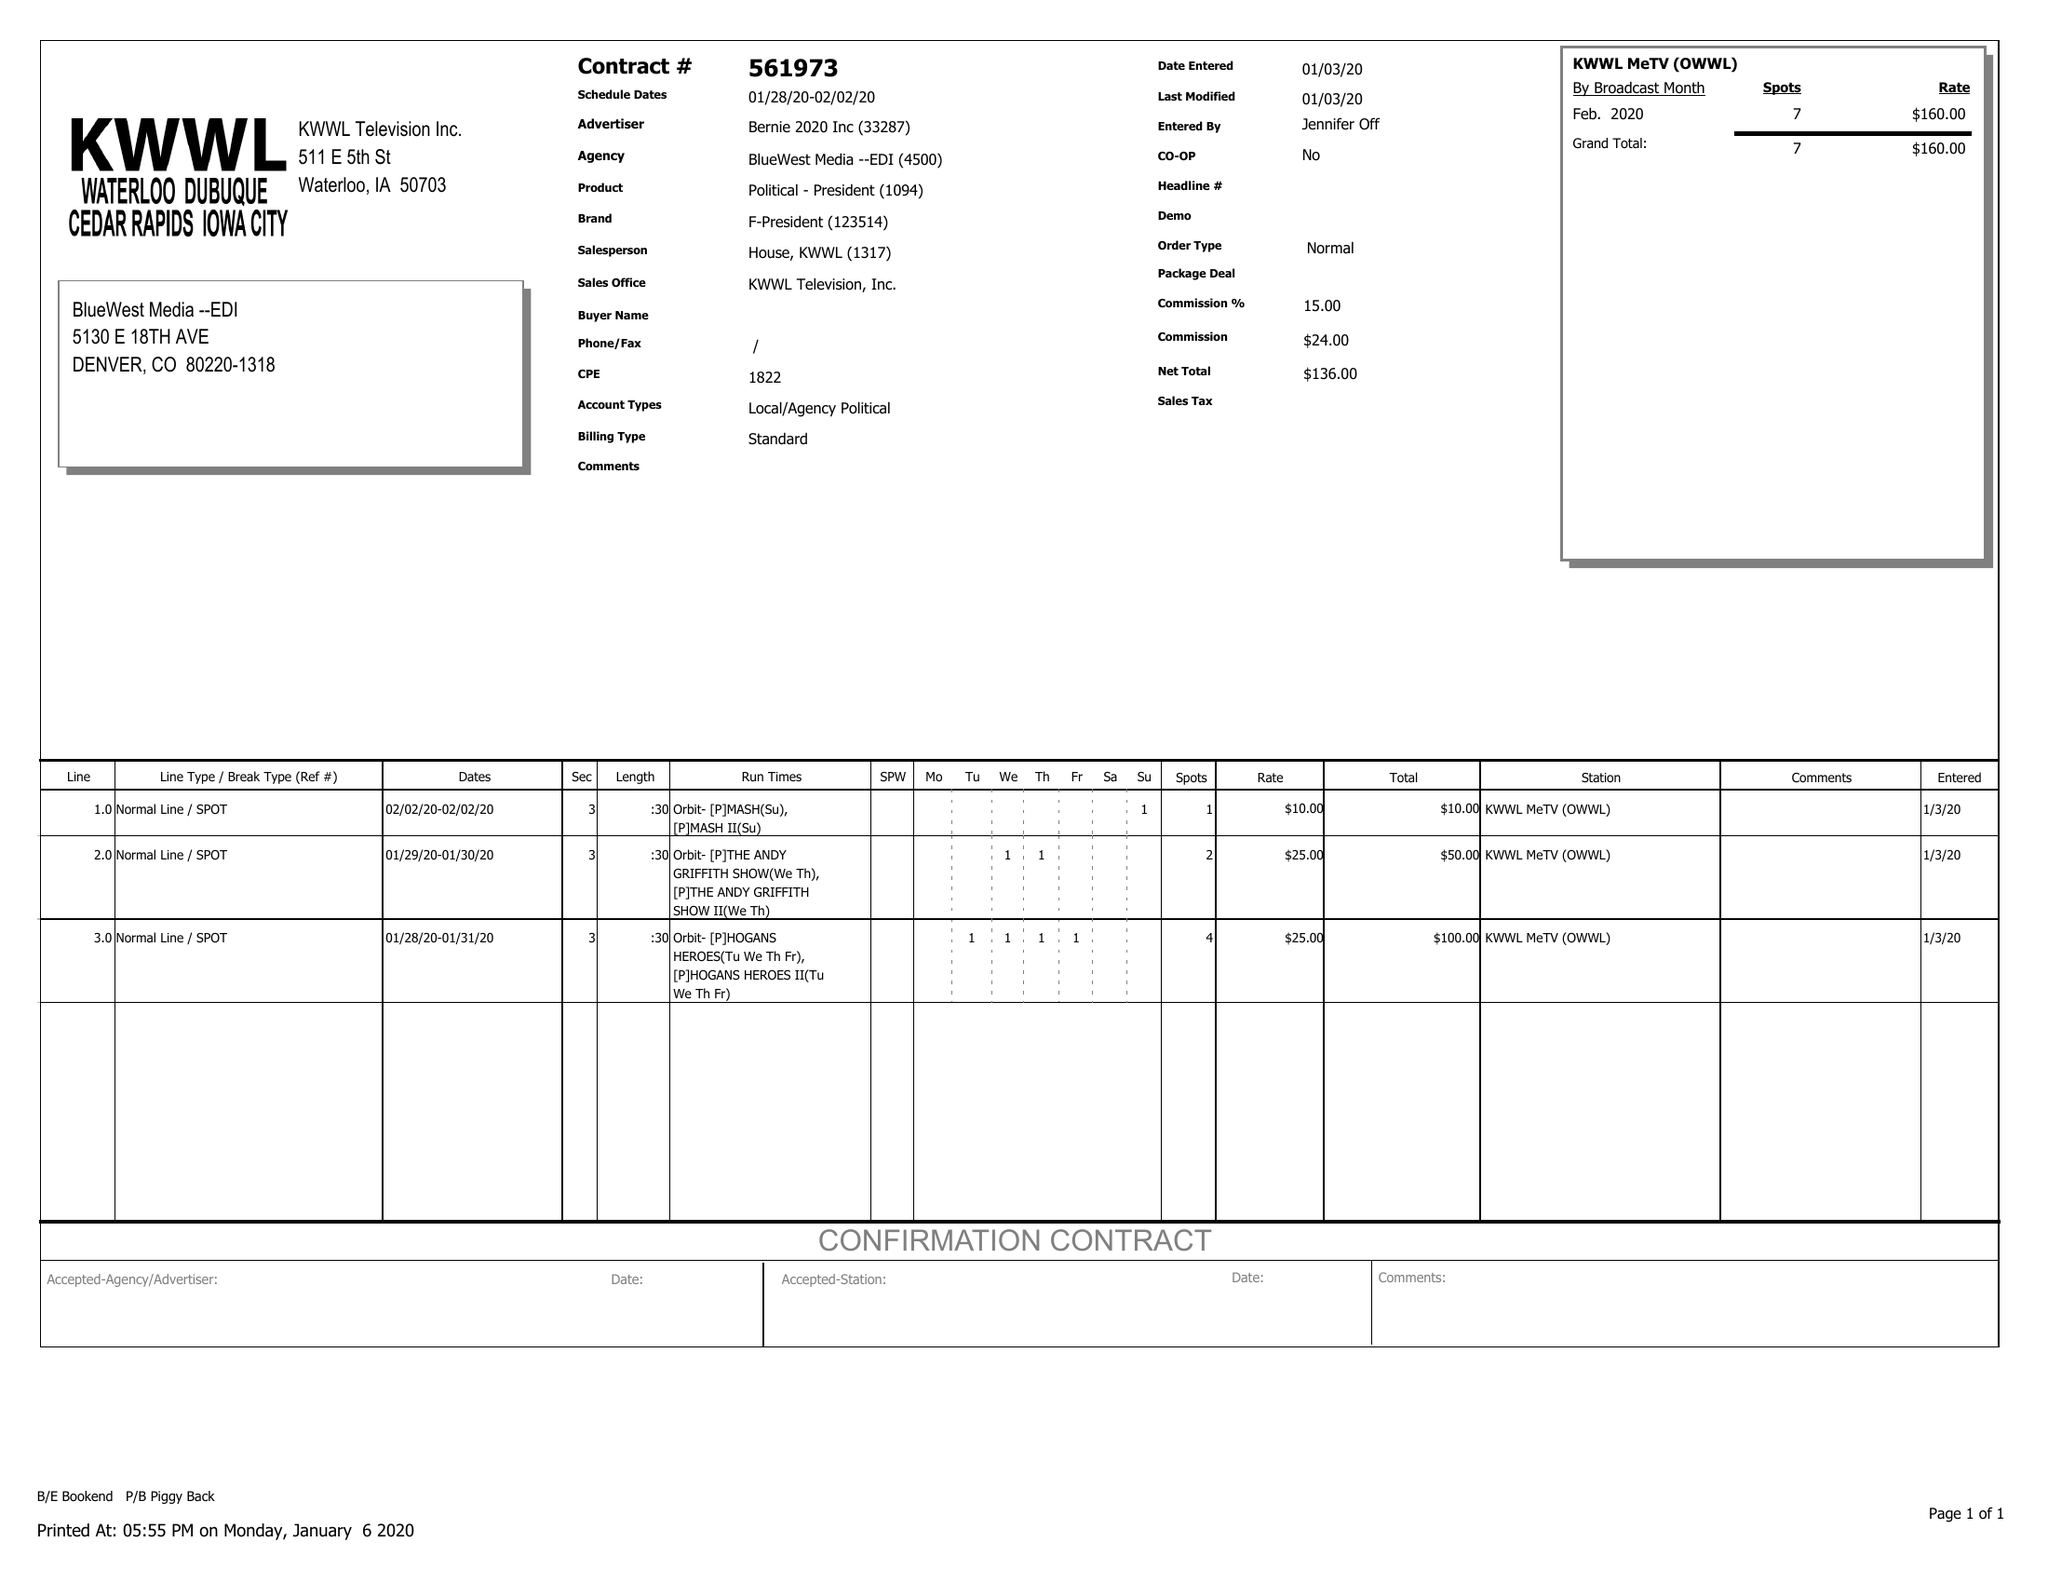What is the value for the advertiser?
Answer the question using a single word or phrase. BERNIE 2020 INC 